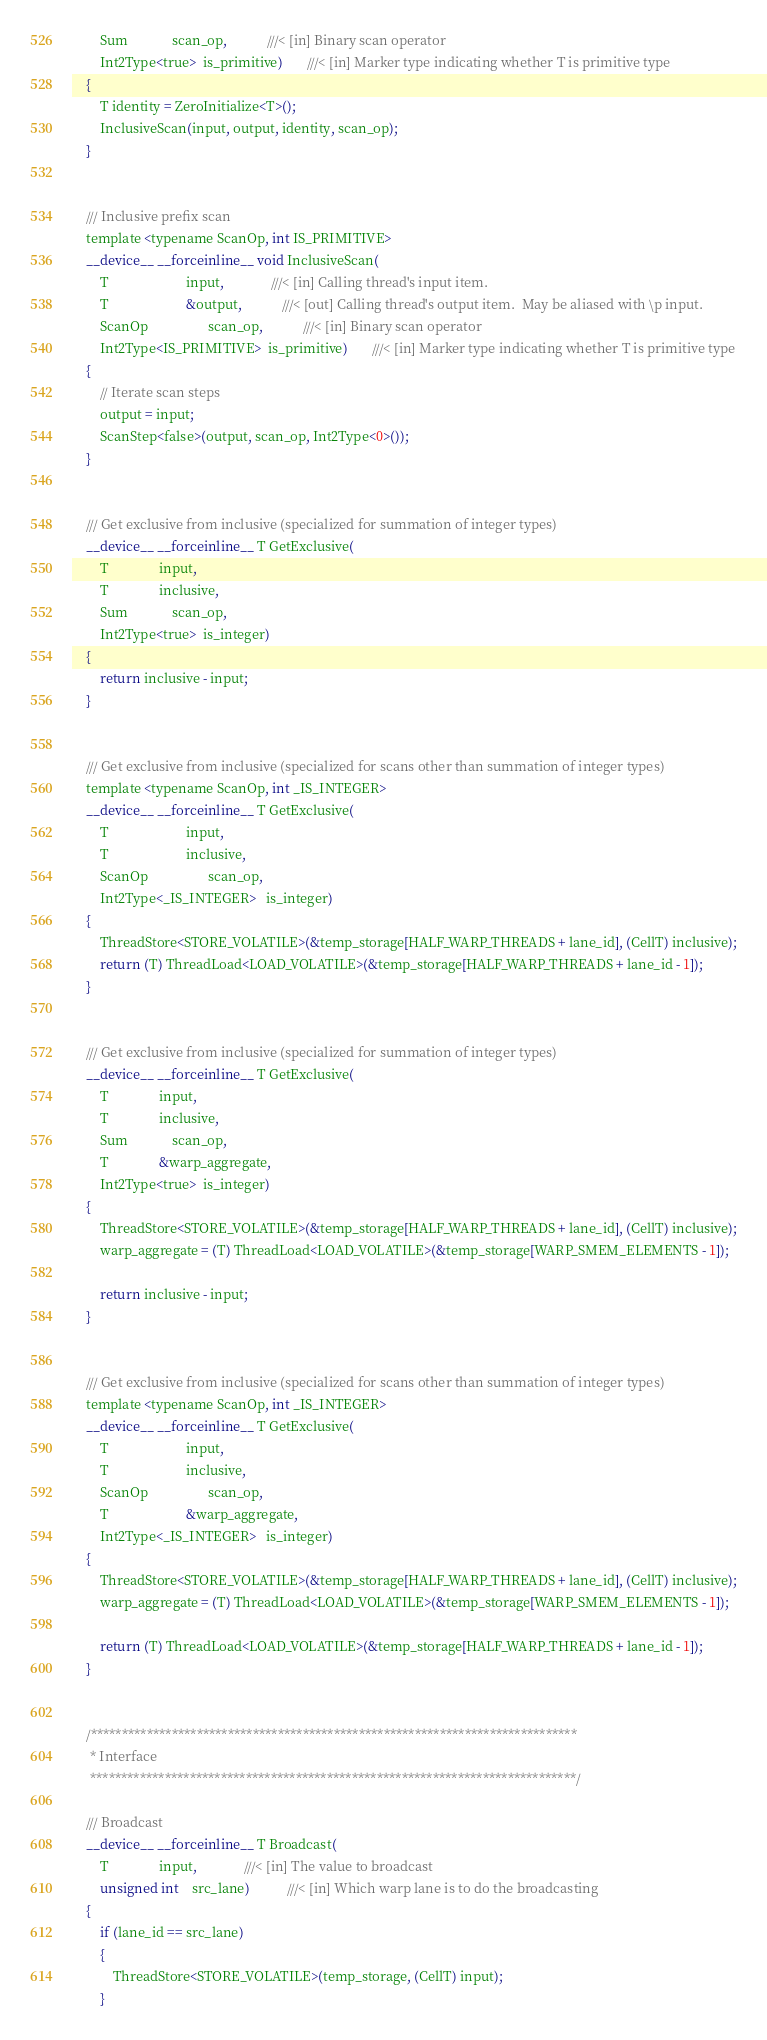Convert code to text. <code><loc_0><loc_0><loc_500><loc_500><_Cuda_>        Sum             scan_op,            ///< [in] Binary scan operator
        Int2Type<true>  is_primitive)       ///< [in] Marker type indicating whether T is primitive type
    {
        T identity = ZeroInitialize<T>();
        InclusiveScan(input, output, identity, scan_op);
    }


    /// Inclusive prefix scan
    template <typename ScanOp, int IS_PRIMITIVE>
    __device__ __forceinline__ void InclusiveScan(
        T                       input,              ///< [in] Calling thread's input item.
        T                       &output,            ///< [out] Calling thread's output item.  May be aliased with \p input.
        ScanOp                  scan_op,            ///< [in] Binary scan operator
        Int2Type<IS_PRIMITIVE>  is_primitive)       ///< [in] Marker type indicating whether T is primitive type
    {
        // Iterate scan steps
        output = input;
        ScanStep<false>(output, scan_op, Int2Type<0>());
    }


    /// Get exclusive from inclusive (specialized for summation of integer types)
    __device__ __forceinline__ T GetExclusive(
        T               input,
        T               inclusive,
        Sum             scan_op,
        Int2Type<true>  is_integer)
    {
        return inclusive - input;
    }


    /// Get exclusive from inclusive (specialized for scans other than summation of integer types)
    template <typename ScanOp, int _IS_INTEGER>
    __device__ __forceinline__ T GetExclusive(
        T                       input,
        T                       inclusive,
        ScanOp                  scan_op,
        Int2Type<_IS_INTEGER>   is_integer)
    {
        ThreadStore<STORE_VOLATILE>(&temp_storage[HALF_WARP_THREADS + lane_id], (CellT) inclusive);
        return (T) ThreadLoad<LOAD_VOLATILE>(&temp_storage[HALF_WARP_THREADS + lane_id - 1]);
    }


    /// Get exclusive from inclusive (specialized for summation of integer types)
    __device__ __forceinline__ T GetExclusive(
        T               input,
        T               inclusive,
        Sum             scan_op,
        T               &warp_aggregate,
        Int2Type<true>  is_integer)
    {
        ThreadStore<STORE_VOLATILE>(&temp_storage[HALF_WARP_THREADS + lane_id], (CellT) inclusive);
        warp_aggregate = (T) ThreadLoad<LOAD_VOLATILE>(&temp_storage[WARP_SMEM_ELEMENTS - 1]);

        return inclusive - input;
    }


    /// Get exclusive from inclusive (specialized for scans other than summation of integer types)
    template <typename ScanOp, int _IS_INTEGER>
    __device__ __forceinline__ T GetExclusive(
        T                       input,
        T                       inclusive,
        ScanOp                  scan_op,
        T                       &warp_aggregate,
        Int2Type<_IS_INTEGER>   is_integer)
    {
        ThreadStore<STORE_VOLATILE>(&temp_storage[HALF_WARP_THREADS + lane_id], (CellT) inclusive);
        warp_aggregate = (T) ThreadLoad<LOAD_VOLATILE>(&temp_storage[WARP_SMEM_ELEMENTS - 1]);

        return (T) ThreadLoad<LOAD_VOLATILE>(&temp_storage[HALF_WARP_THREADS + lane_id - 1]);
    }


    /******************************************************************************
     * Interface
     ******************************************************************************/

    /// Broadcast
    __device__ __forceinline__ T Broadcast(
        T               input,              ///< [in] The value to broadcast
        unsigned int    src_lane)           ///< [in] Which warp lane is to do the broadcasting
    {
        if (lane_id == src_lane)
        {
            ThreadStore<STORE_VOLATILE>(temp_storage, (CellT) input);
        }
</code> 